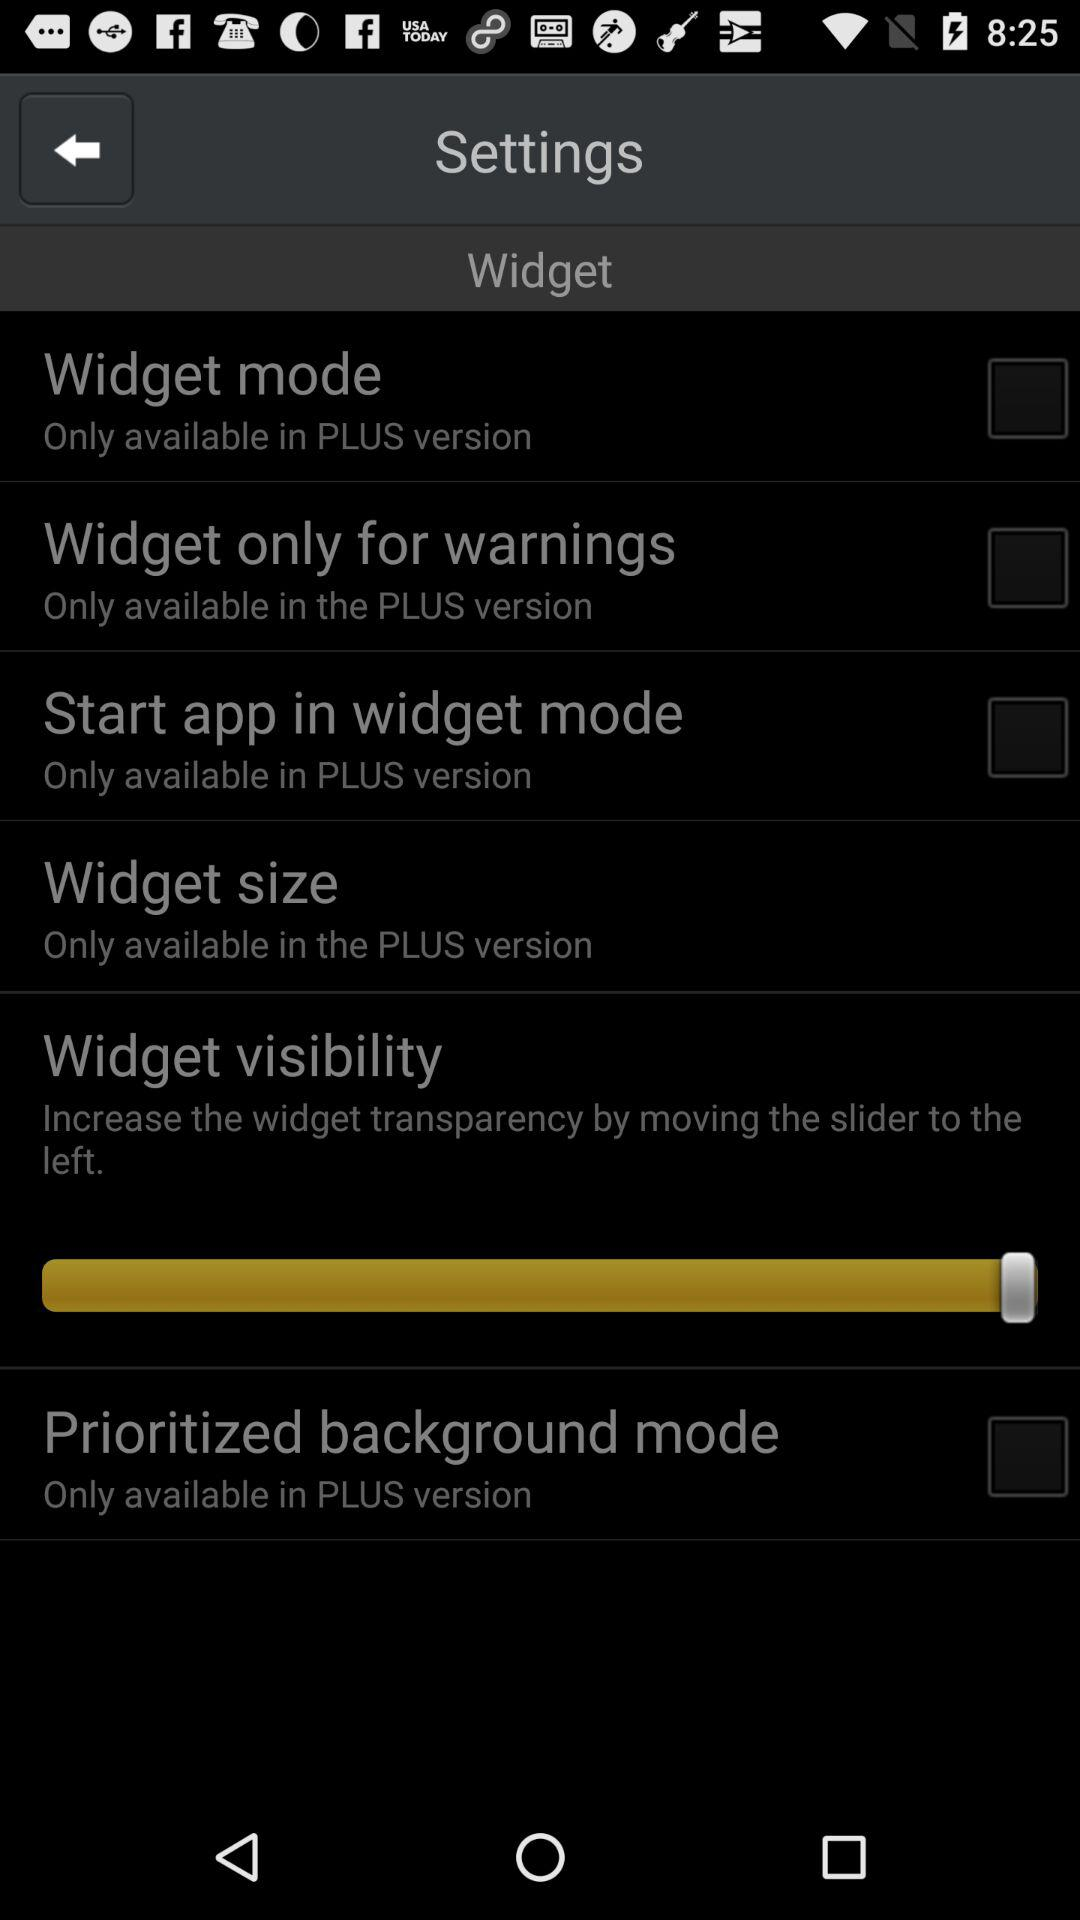In which version is the widget mode only available? The widget mode is only available in the PLUS version. 